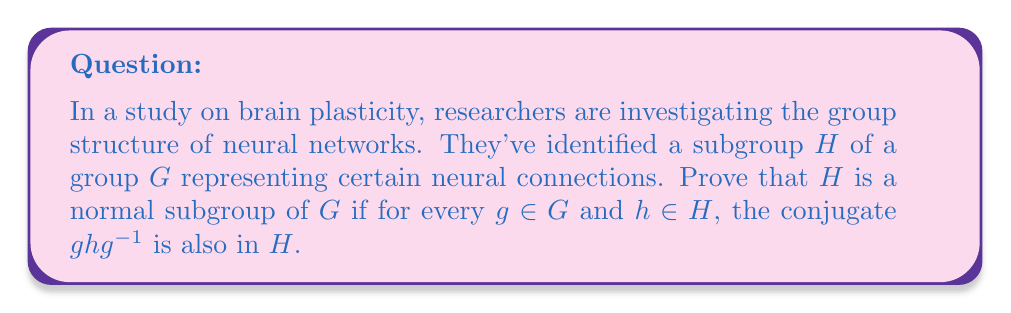Provide a solution to this math problem. To prove that $H$ is a normal subgroup of $G$, we need to show that for all $g \in G$, $gHg^{-1} \subseteq H$. This is equivalent to showing that for all $g \in G$ and $h \in H$, $ghg^{-1} \in H$.

Let's approach this step-by-step:

1) We are given that for every $g \in G$ and $h \in H$, $ghg^{-1} \in H$.

2) This directly satisfies the definition of a normal subgroup. To see why, let's consider the set $gHg^{-1}$:

   $gHg^{-1} = \{ghg^{-1} : h \in H\}$

3) By the given condition, each element $ghg^{-1}$ in this set is in $H$.

4) Therefore, $gHg^{-1} \subseteq H$ for all $g \in G$.

5) This is precisely the definition of a normal subgroup.

The condition given in the problem is actually a stronger condition than necessary for normality. It states that each individual conjugate is in $H$, which implies that the entire conjugate subgroup is in $H$.

This proof demonstrates how the structure of neural networks, when viewed through the lens of group theory, can exhibit properties like normality, which may have implications for understanding brain plasticity and learning processes.
Answer: $H$ is a normal subgroup of $G$ because the given condition $ghg^{-1} \in H$ for all $g \in G$ and $h \in H$ directly implies that $gHg^{-1} \subseteq H$ for all $g \in G$, which is the definition of a normal subgroup. 